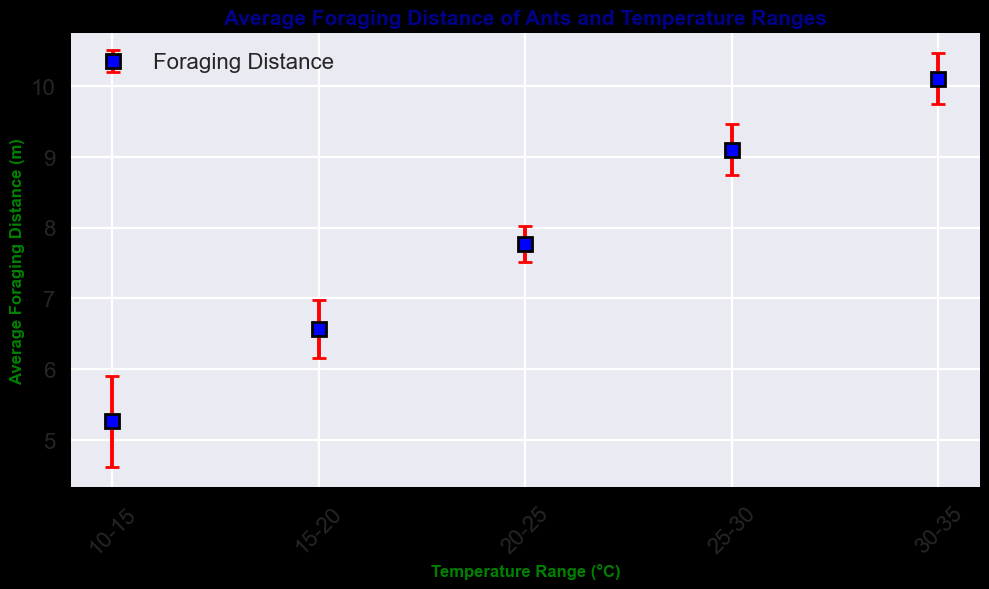What temperature range do ants forage the least distance on average? The lowest average foraging distance will have the smallest mean value of foraging distance. By looking at the chart, the temperature range 10-15°C has the smallest mean foraging distance.
Answer: 10-15°C What temperature range do ants forage the farthest distance on average? The highest average foraging distance will have the largest mean value of foraging distance. By looking at the chart, the temperature range 30-35°C has the largest mean foraging distance.
Answer: 30-35°C Which temperature range shows the largest error in foraging distance, and what are the error bars' heights? The largest error in foraging distance is represented by the tallest error bars. By examining the chart, the temperature range 30-35°C has the tallest error bars. The error bar height for this range is 1.0.
Answer: 30-35°C, 1.0 How does the average foraging distance change as the temperature increases from 10-15°C to 30-35°C? To find out how the average changes, observe the trend of the means in the chart as the temperature range increases. The average foraging distance steadily increases from 10-15°C to 30-35°C.
Answer: Increases In which temperature range is the average foraging distance closest to 9 meters? The temperature range with a mean foraging distance closest to 9 meters will be identified by observing the means. The 25-30°C range has an average foraging distance of 9 meters.
Answer: 25-30°C What is the average distance for ants at 20-25°C and the standard deviation for that range? Look at the mean and the height of the error bars for the 20-25°C range in the chart. The average foraging distance is 7.8 meters and the standard deviation is 0.8 meters.
Answer: 7.8 meters, 0.8 meters Is the average foraging distance more variable at the range 10-15°C or 30-35°C? Variability is indicated by the height of the error bars. By comparing the error bars, the range 30-35°C has a larger standard deviation (1.0) compared to the range 10-15°C (0.5), indicating more variability.
Answer: 30-35°C Which temperature range has its error bar height equal to 0.7, and what is the mean value for that range? Look for the range where the error bar height is 0.7. For the 15-20°C range, the error bar height is 0.7. The mean value is 6.5 meters.
Answer: 15-20°C, 6.5 meters 